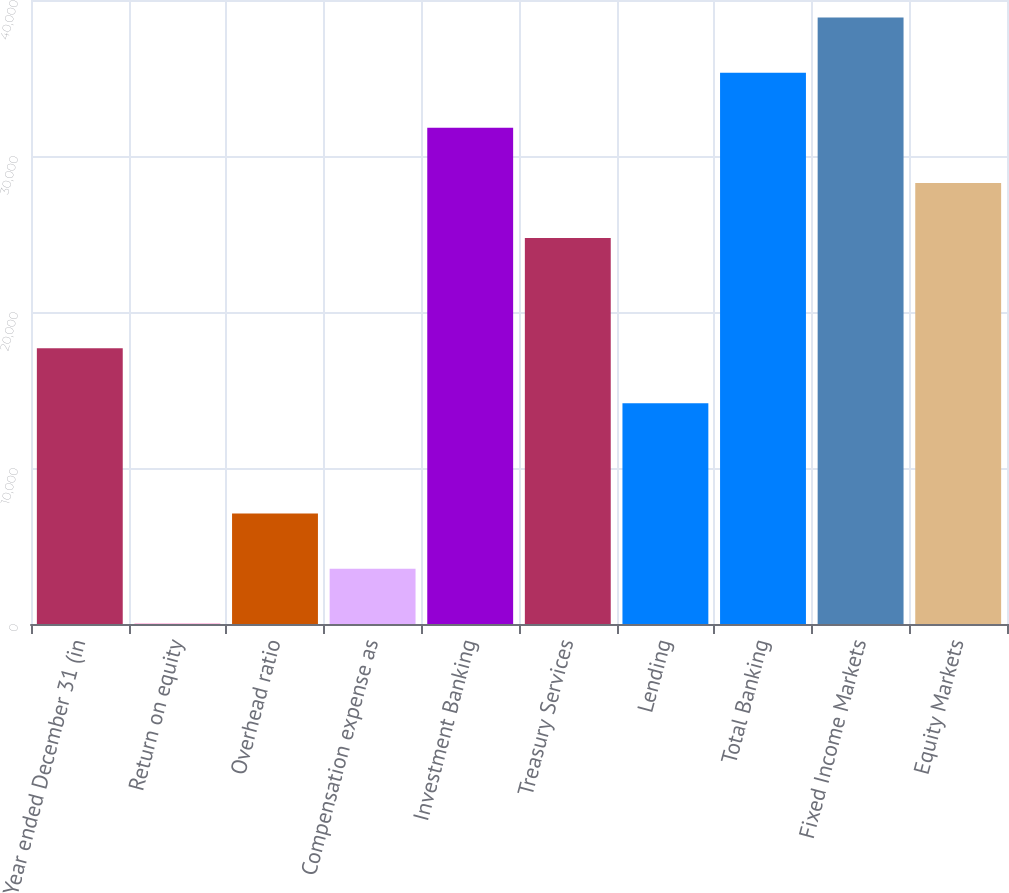<chart> <loc_0><loc_0><loc_500><loc_500><bar_chart><fcel>Year ended December 31 (in<fcel>Return on equity<fcel>Overhead ratio<fcel>Compensation expense as<fcel>Investment Banking<fcel>Treasury Services<fcel>Lending<fcel>Total Banking<fcel>Fixed Income Markets<fcel>Equity Markets<nl><fcel>17678<fcel>16<fcel>7080.8<fcel>3548.4<fcel>31807.6<fcel>24742.8<fcel>14145.6<fcel>35340<fcel>38872.4<fcel>28275.2<nl></chart> 